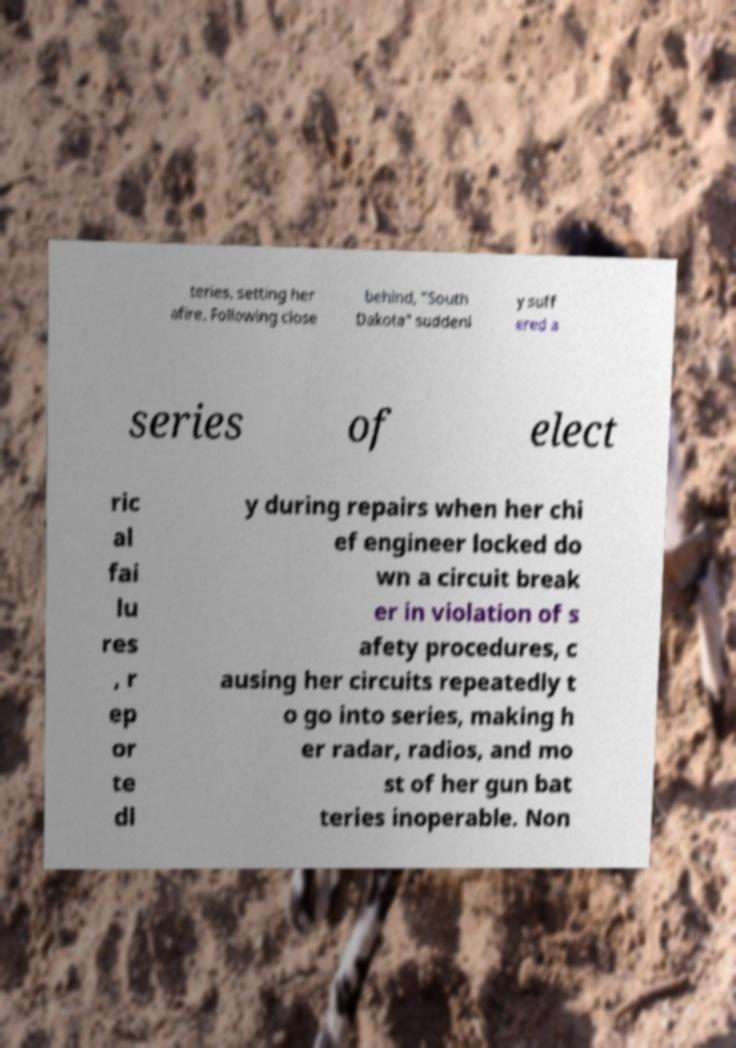Could you extract and type out the text from this image? teries, setting her afire. Following close behind, "South Dakota" suddenl y suff ered a series of elect ric al fai lu res , r ep or te dl y during repairs when her chi ef engineer locked do wn a circuit break er in violation of s afety procedures, c ausing her circuits repeatedly t o go into series, making h er radar, radios, and mo st of her gun bat teries inoperable. Non 